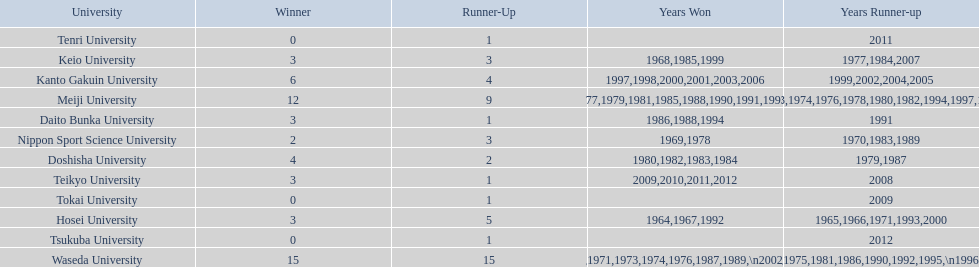Hosei won in 1964. who won the next year? Waseda University. 